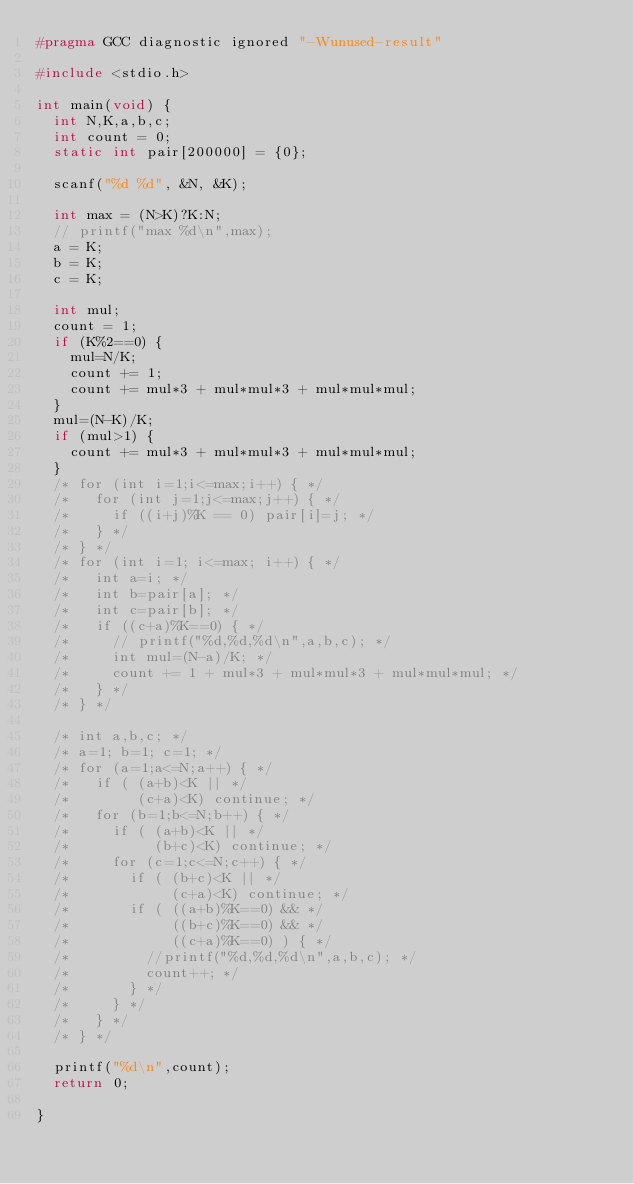Convert code to text. <code><loc_0><loc_0><loc_500><loc_500><_C_>#pragma GCC diagnostic ignored "-Wunused-result"

#include <stdio.h>

int main(void) {
  int N,K,a,b,c;
  int count = 0;
  static int pair[200000] = {0};
  
  scanf("%d %d", &N, &K);

  int max = (N>K)?K:N;
  // printf("max %d\n",max);
  a = K;
  b = K;
  c = K;

  int mul;
  count = 1;
  if (K%2==0) {
    mul=N/K;
    count += 1;
    count += mul*3 + mul*mul*3 + mul*mul*mul;
  }
  mul=(N-K)/K;
  if (mul>1) {
    count += mul*3 + mul*mul*3 + mul*mul*mul;
  }
  /* for (int i=1;i<=max;i++) { */
  /*   for (int j=1;j<=max;j++) { */
  /*     if ((i+j)%K == 0) pair[i]=j; */
  /*   } */
  /* } */
  /* for (int i=1; i<=max; i++) { */
  /*   int a=i; */
  /*   int b=pair[a]; */
  /*   int c=pair[b]; */
  /*   if ((c+a)%K==0) { */
  /*     // printf("%d,%d,%d\n",a,b,c); */
  /*     int mul=(N-a)/K; */
  /*     count += 1 + mul*3 + mul*mul*3 + mul*mul*mul; */
  /*   } */
  /* } */
  
  /* int a,b,c; */
  /* a=1; b=1; c=1; */
  /* for (a=1;a<=N;a++) { */
  /*   if ( (a+b)<K || */
  /*        (c+a)<K) continue; */
  /*   for (b=1;b<=N;b++) { */
  /*     if ( (a+b)<K || */
  /*          (b+c)<K) continue; */
  /*     for (c=1;c<=N;c++) { */
  /*       if ( (b+c)<K || */
  /*            (c+a)<K) continue; */
  /*       if ( ((a+b)%K==0) && */
  /*            ((b+c)%K==0) && */
  /*            ((c+a)%K==0) ) { */
  /*         //printf("%d,%d,%d\n",a,b,c); */
  /*         count++; */
  /*       } */
  /*     } */
  /*   } */
  /* } */

  printf("%d\n",count);
  return 0;

}
</code> 